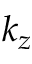Convert formula to latex. <formula><loc_0><loc_0><loc_500><loc_500>k _ { z }</formula> 